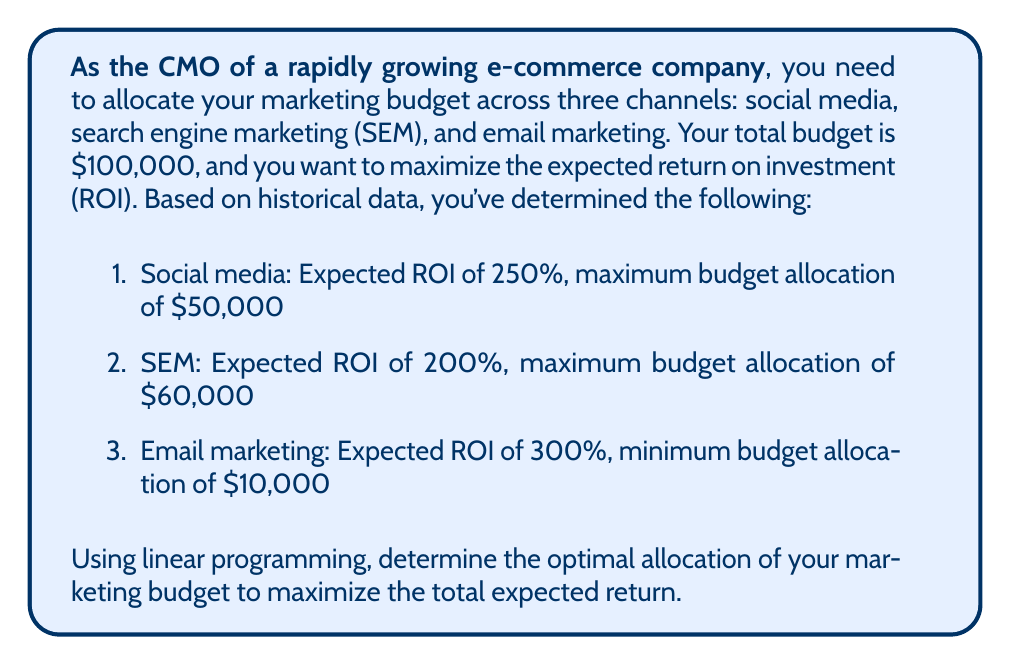Teach me how to tackle this problem. To solve this problem using linear programming, we need to follow these steps:

1. Define the decision variables:
   Let $x_1$, $x_2$, and $x_3$ represent the budget allocated to social media, SEM, and email marketing, respectively.

2. Set up the objective function:
   We want to maximize the total expected return, which is the sum of the ROI for each channel multiplied by the allocated budget.
   
   Maximize: $Z = 2.5x_1 + 2x_2 + 3x_3$

3. Define the constraints:
   a) Total budget constraint: $x_1 + x_2 + x_3 \leq 100000$
   b) Social media maximum: $x_1 \leq 50000$
   c) SEM maximum: $x_2 \leq 60000$
   d) Email marketing minimum: $x_3 \geq 10000$
   e) Non-negativity constraints: $x_1, x_2, x_3 \geq 0$

4. Solve the linear programming problem:
   We can use the simplex method or a linear programming solver to find the optimal solution.

   The optimal solution is:
   $x_1 = 30000$ (Social media)
   $x_2 = 60000$ (SEM)
   $x_3 = 10000$ (Email marketing)

5. Calculate the maximum expected return:
   $Z = 2.5(30000) + 2(60000) + 3(10000) = 75000 + 120000 + 30000 = 225000$

This allocation maximizes the expected return while satisfying all constraints. The solution allocates the maximum amount to SEM, the minimum required amount to email marketing, and the remaining budget to social media.
Answer: The optimal allocation of the marketing budget is:
Social media: $30,000
SEM: $60,000
Email marketing: $10,000

The maximum expected return is $225,000. 